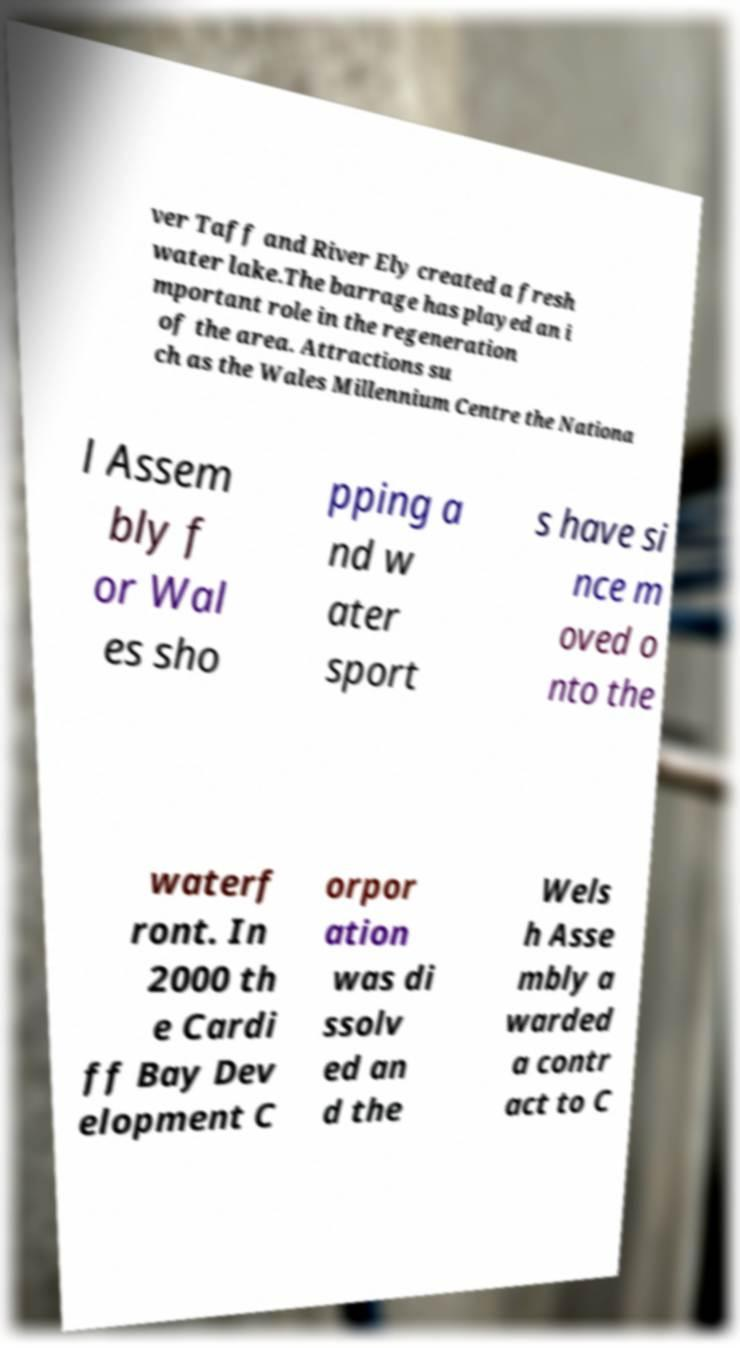Please identify and transcribe the text found in this image. ver Taff and River Ely created a fresh water lake.The barrage has played an i mportant role in the regeneration of the area. Attractions su ch as the Wales Millennium Centre the Nationa l Assem bly f or Wal es sho pping a nd w ater sport s have si nce m oved o nto the waterf ront. In 2000 th e Cardi ff Bay Dev elopment C orpor ation was di ssolv ed an d the Wels h Asse mbly a warded a contr act to C 